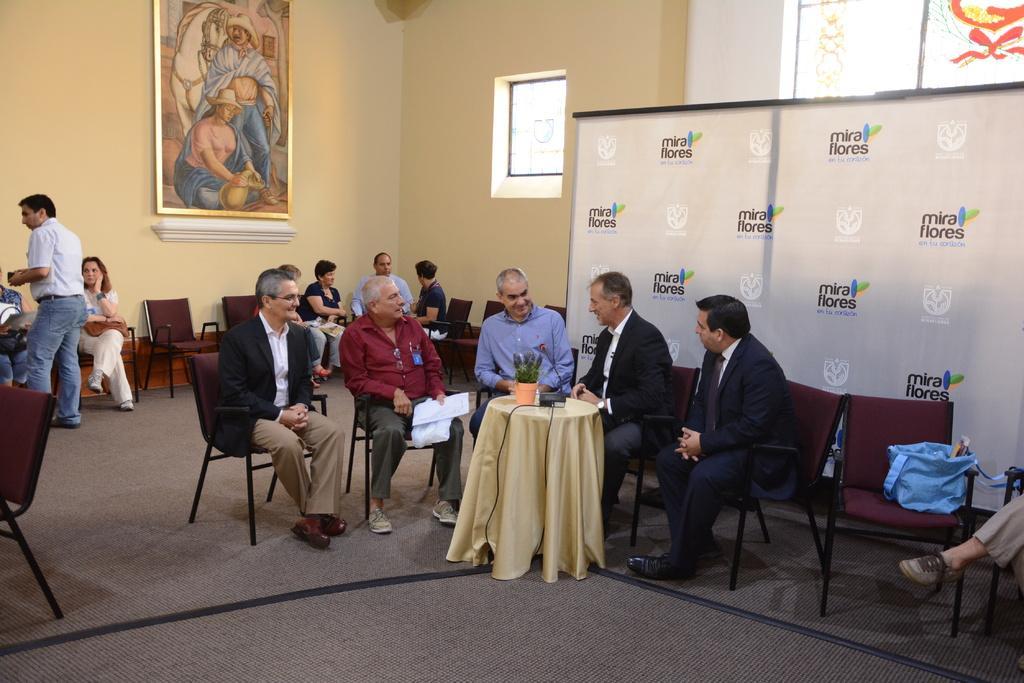Can you describe this image briefly? In this image there are group of people. At the right side of the image there is a hoarding and at the back side there is a painting on the wall, there is a house plant on the table, table is covered with the golden color cloth. 